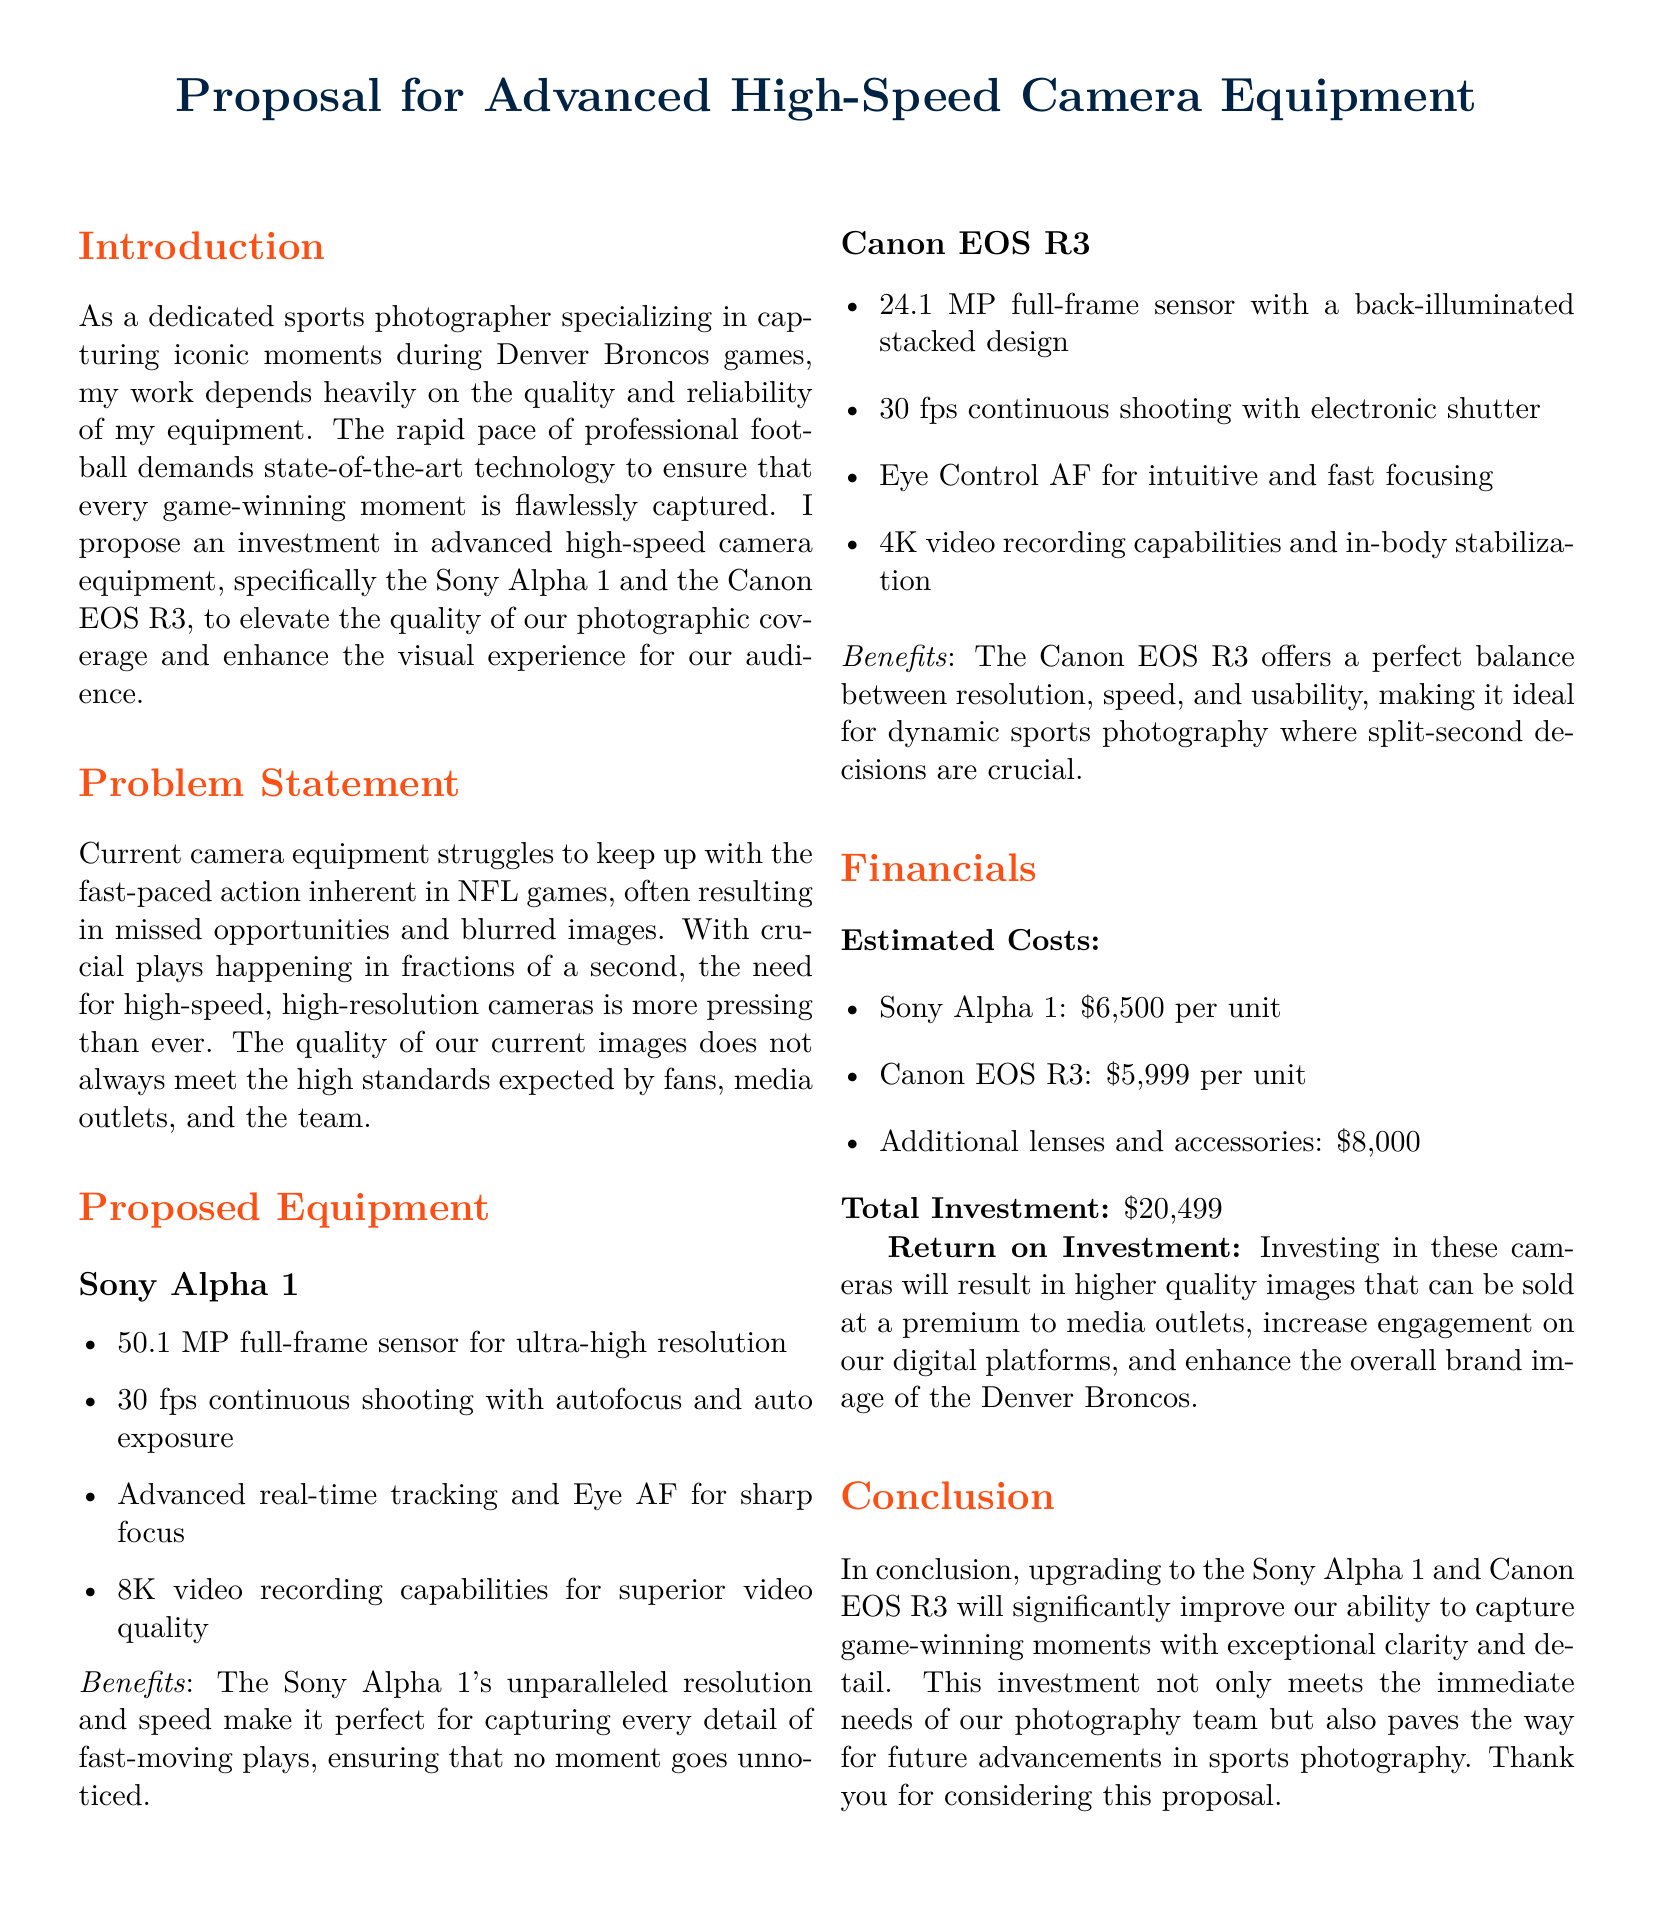What is the proposal about? The proposal focuses on investing in advanced high-speed camera equipment to improve photography during Denver Broncos games.
Answer: Advanced high-speed camera equipment What are the two camera models proposed? The document lists two specific camera models recommended for purchase.
Answer: Sony Alpha 1 and Canon EOS R3 What is the estimated cost of the Sony Alpha 1? The document specifies the individual cost of the Sony Alpha 1 camera.
Answer: $6,500 What is the total investment required? The total investment is the sum of the costs of the proposed equipment and accessories mentioned in the financials section.
Answer: $20,499 How many frames per second can the Canon EOS R3 shoot? The proposal provides a specific shooting speed for the Canon EOS R3 under proposed equipment.
Answer: 30 fps What is the main problem stated in the proposal? The problem statement addresses the challenges currently faced in capturing fast-paced football action.
Answer: Blurred images and missed opportunities What are the benefits of the Sony Alpha 1? The proposal lists benefits specifically related to the high-speed camera model being discussed.
Answer: Perfect for capturing every detail of fast-moving plays What is the back-illuminated sensor design associated with? This term refers to a specific technical feature of one of the proposed cameras, enhancing its performance.
Answer: Canon EOS R3 What will higher quality images result in? The proposal mentions expected outcomes from investing in new camera equipment and improving image quality.
Answer: Higher quality images that can be sold at a premium 